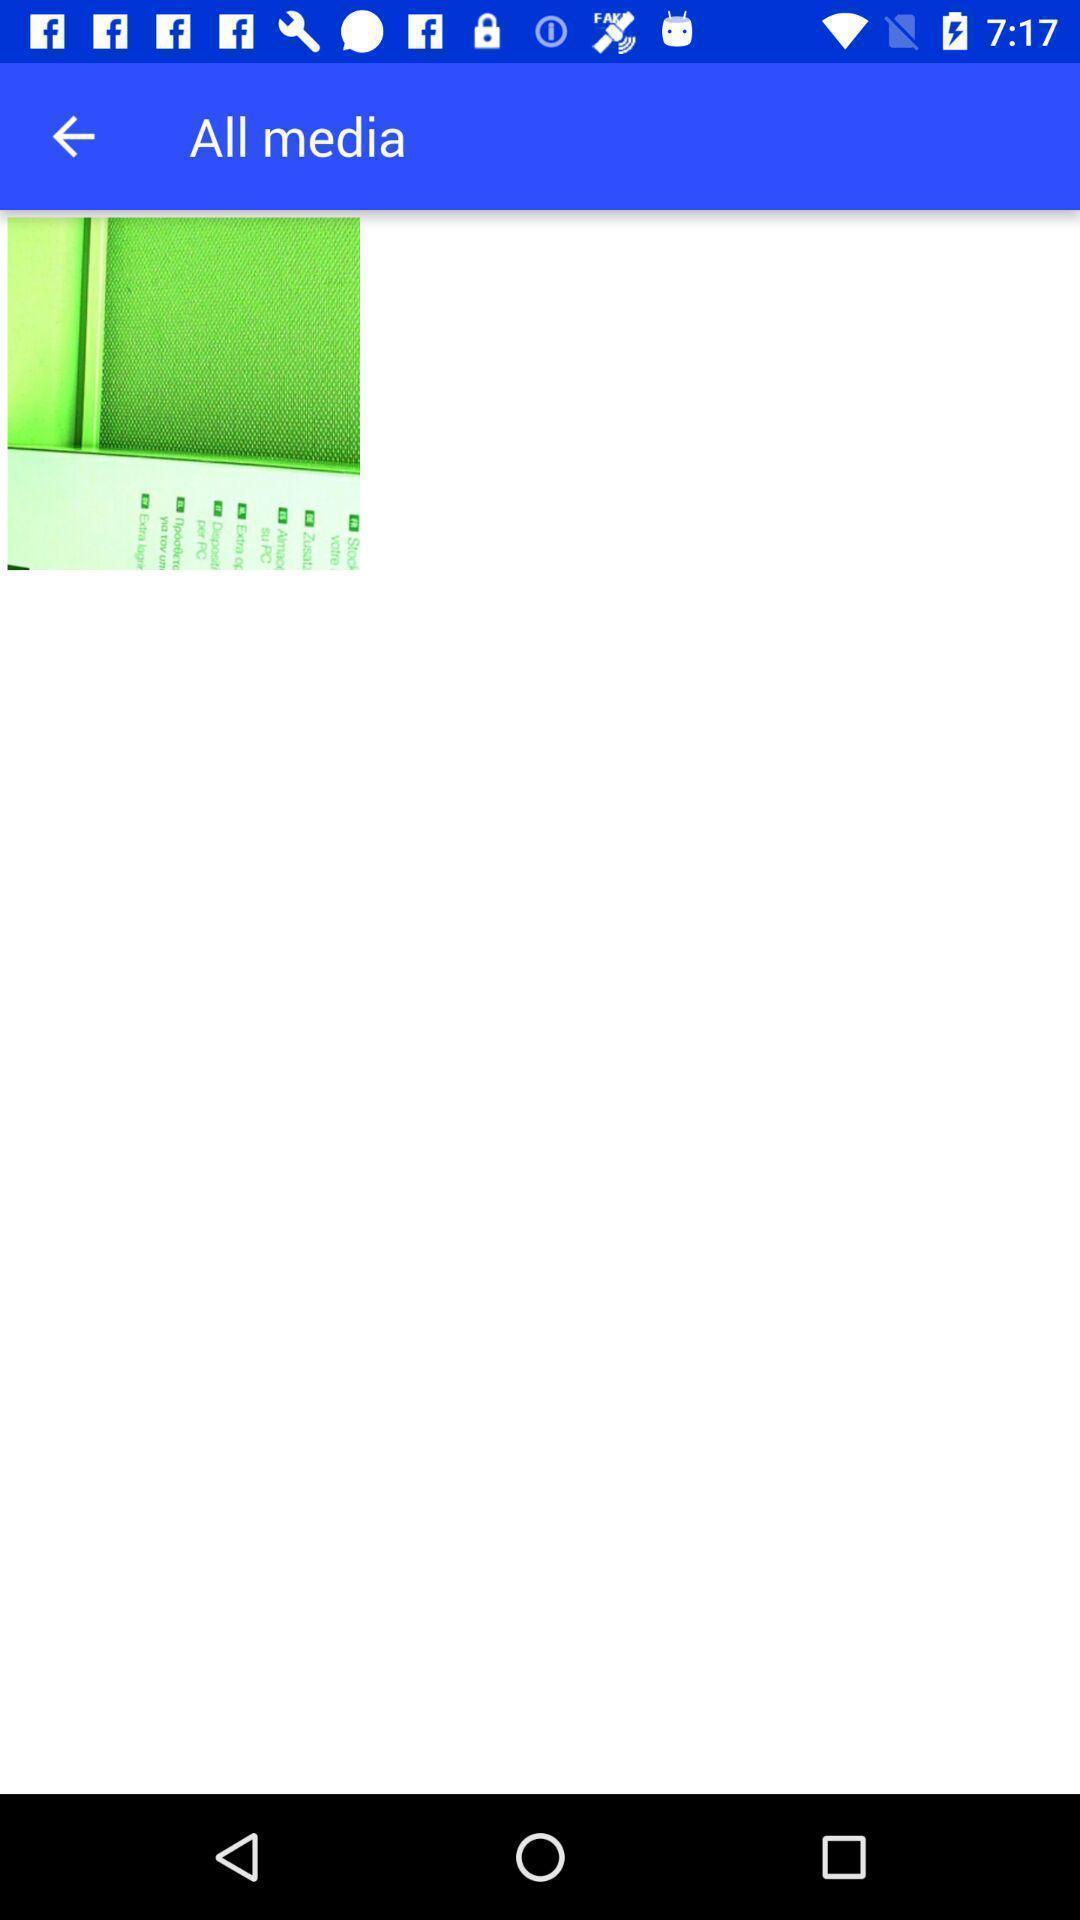Describe the key features of this screenshot. Page showing the image under all media. 